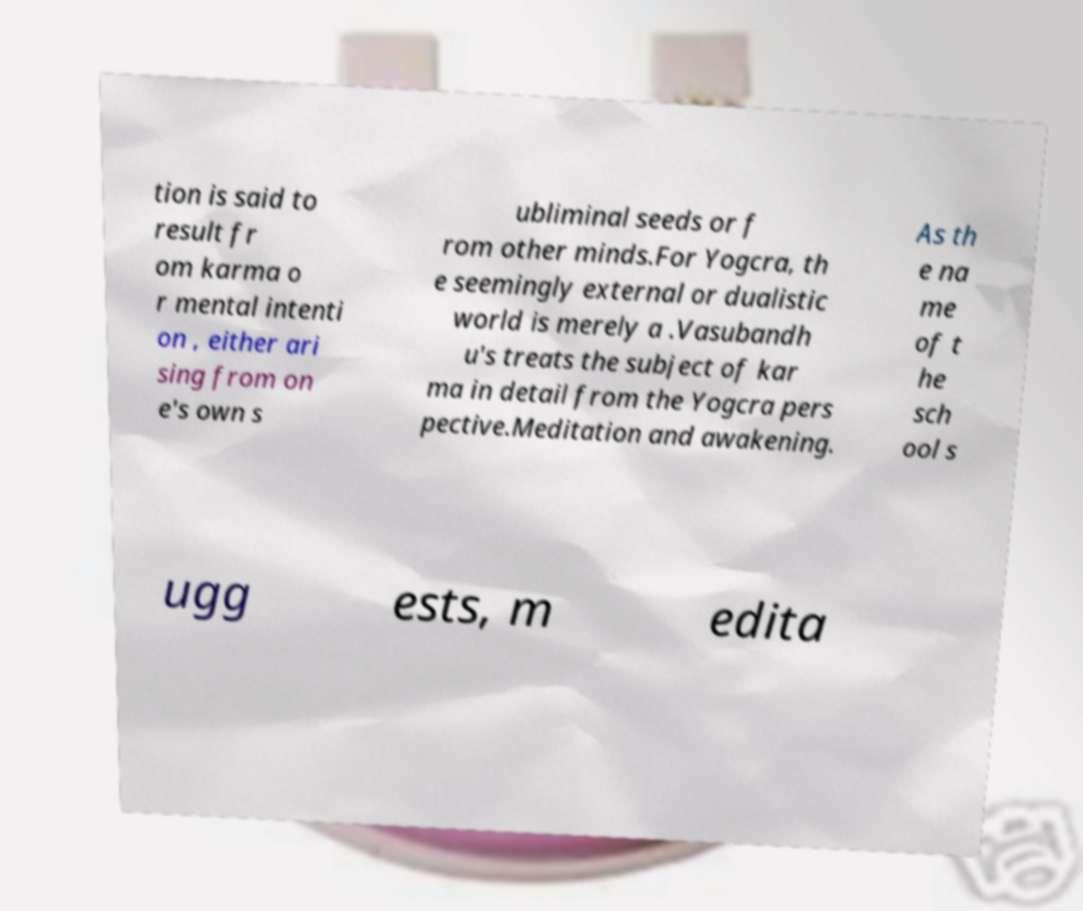Could you assist in decoding the text presented in this image and type it out clearly? tion is said to result fr om karma o r mental intenti on , either ari sing from on e's own s ubliminal seeds or f rom other minds.For Yogcra, th e seemingly external or dualistic world is merely a .Vasubandh u's treats the subject of kar ma in detail from the Yogcra pers pective.Meditation and awakening. As th e na me of t he sch ool s ugg ests, m edita 